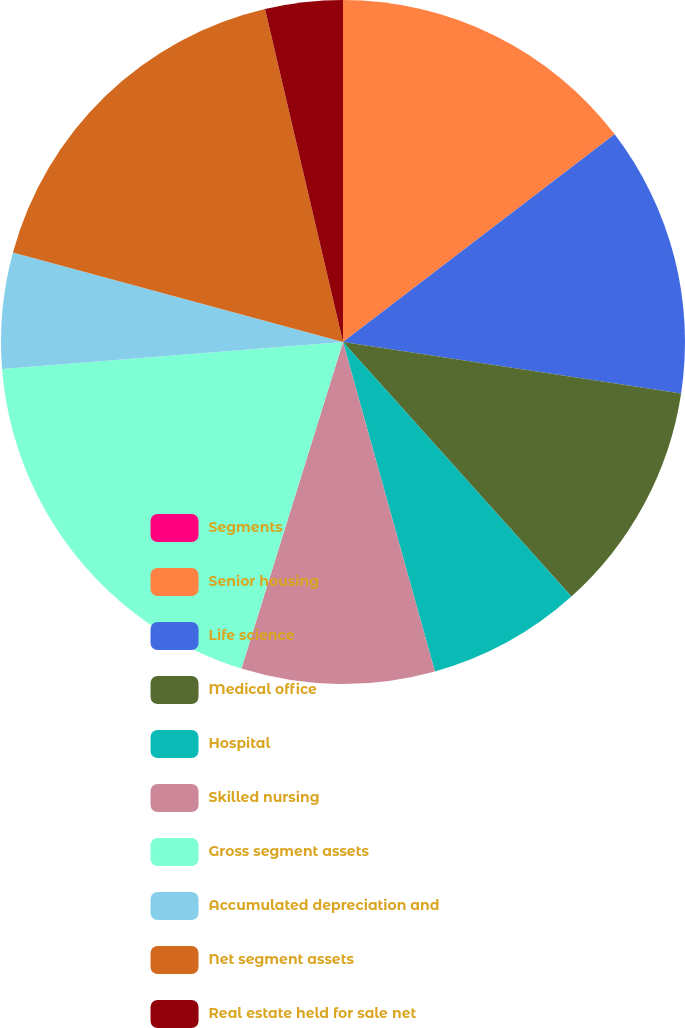<chart> <loc_0><loc_0><loc_500><loc_500><pie_chart><fcel>Segments<fcel>Senior housing<fcel>Life science<fcel>Medical office<fcel>Hospital<fcel>Skilled nursing<fcel>Gross segment assets<fcel>Accumulated depreciation and<fcel>Net segment assets<fcel>Real estate held for sale net<nl><fcel>0.0%<fcel>14.61%<fcel>12.79%<fcel>10.96%<fcel>7.31%<fcel>9.13%<fcel>18.94%<fcel>5.48%<fcel>17.12%<fcel>3.66%<nl></chart> 